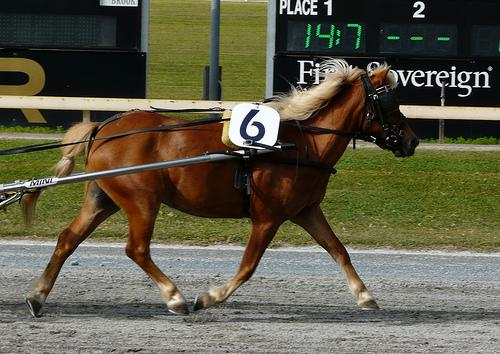How many legs of the horse are visible in the image and what distinguishing feature do they have? Four legs of the horse are visible, and they all have white markings at the bottom. Identify the animal that is featured in this image and describe its appearance. A brown horse with a blonde mane and tail is running on a track, with white markings on its lower legs and a determined facial expression. Provide a brief description of the scoreboard present in the image. The scoreboard is an electronic sign, showing first sovereign in place 1 and 2, positioned at the top-left corner of the image. What type of track surface is the horse running on in this image? The horse is running on a gray track surface. Describe the image's overall sentiment or mood. The image has a competitive and energetic mood, as it captures a moment from a horse race in progress. Identify any close-up details visible in the image related to the horse's anatomy. The head of the horse, mouth, and hair are visible, as well as four legs, and the tail of the horse. What type of sports scene is depicted in this image? This image shows a horse racing event with a brown horse running on a gray track, surrounded by a green field. Examine the interactions between different objects within the image. The horse is interacting with the track as it runs, while the scoreboard is displaying the race information. Furthermore, the white guard rail is separating the track from the green field. How many objects are mentioned in the image of this image? There are 29 distinct object descriptions mentioned in the bounding box information. Can you describe the setting of this image, including any additional elements? The setting is an outdoor race track with a green field, gray track, and a white guard rail. There's also a white and black sign with the number 6 on it. 